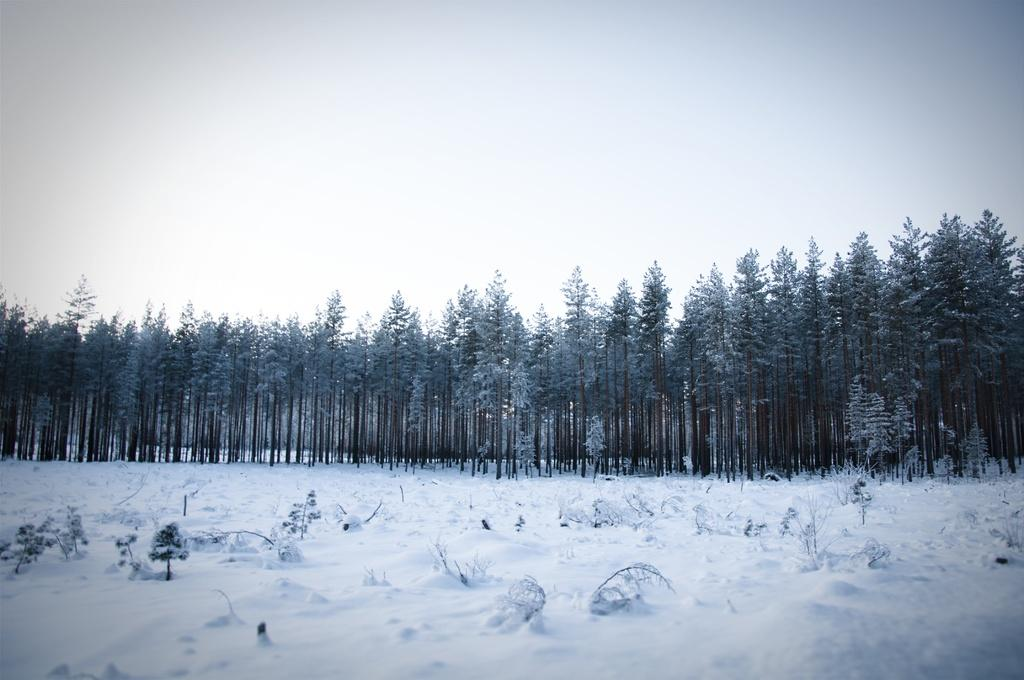What is the primary characteristic of the land in the image? The land is covered with snow. What can be seen in the background of the image? There are trees and the sky visible in the background of the image. What type of engine can be seen powering the school in the image? There is no school or engine present in the image; it features a snow-covered landscape with trees and sky in the background. 